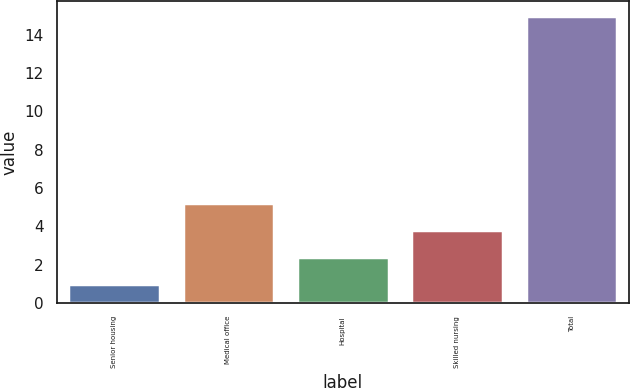Convert chart. <chart><loc_0><loc_0><loc_500><loc_500><bar_chart><fcel>Senior housing<fcel>Medical office<fcel>Hospital<fcel>Skilled nursing<fcel>Total<nl><fcel>1<fcel>5.2<fcel>2.4<fcel>3.8<fcel>15<nl></chart> 